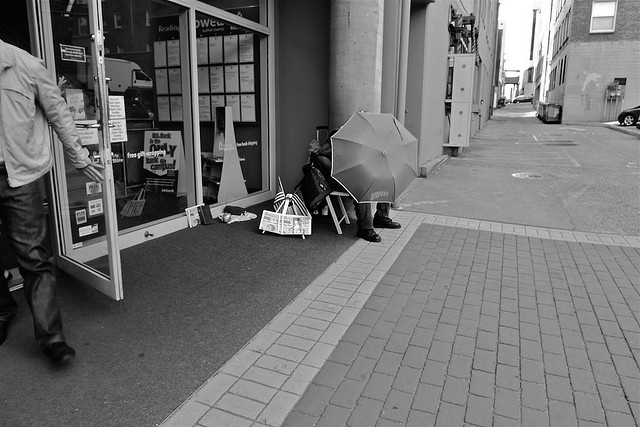Describe the objects in this image and their specific colors. I can see people in black, darkgray, gray, and lightgray tones, umbrella in black, gray, and lightgray tones, people in black, darkgray, gray, and lightgray tones, people in black, gray, lightgray, and darkgray tones, and chair in black, darkgray, gray, and lightgray tones in this image. 